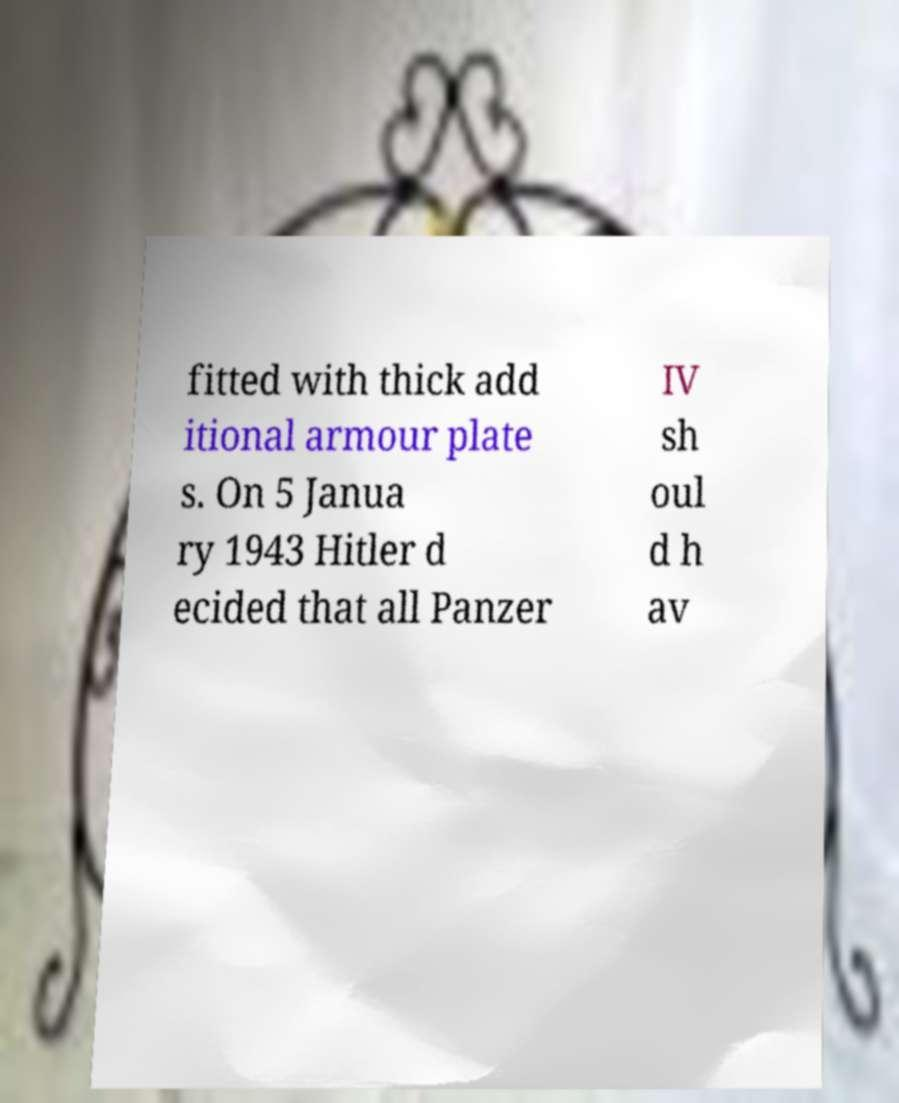Could you extract and type out the text from this image? fitted with thick add itional armour plate s. On 5 Janua ry 1943 Hitler d ecided that all Panzer IV sh oul d h av 